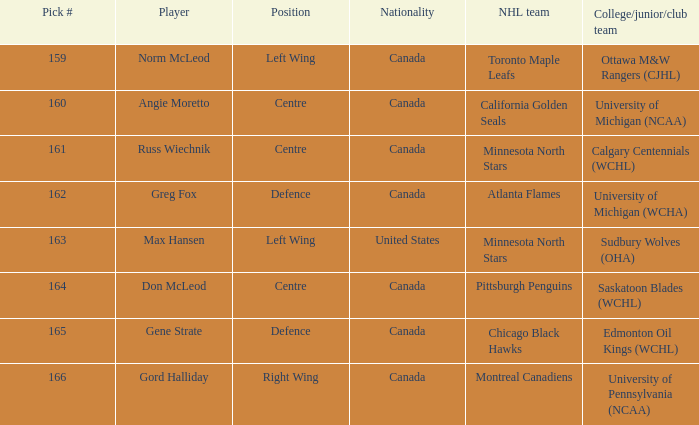Would you mind parsing the complete table? {'header': ['Pick #', 'Player', 'Position', 'Nationality', 'NHL team', 'College/junior/club team'], 'rows': [['159', 'Norm McLeod', 'Left Wing', 'Canada', 'Toronto Maple Leafs', 'Ottawa M&W Rangers (CJHL)'], ['160', 'Angie Moretto', 'Centre', 'Canada', 'California Golden Seals', 'University of Michigan (NCAA)'], ['161', 'Russ Wiechnik', 'Centre', 'Canada', 'Minnesota North Stars', 'Calgary Centennials (WCHL)'], ['162', 'Greg Fox', 'Defence', 'Canada', 'Atlanta Flames', 'University of Michigan (WCHA)'], ['163', 'Max Hansen', 'Left Wing', 'United States', 'Minnesota North Stars', 'Sudbury Wolves (OHA)'], ['164', 'Don McLeod', 'Centre', 'Canada', 'Pittsburgh Penguins', 'Saskatoon Blades (WCHL)'], ['165', 'Gene Strate', 'Defence', 'Canada', 'Chicago Black Hawks', 'Edmonton Oil Kings (WCHL)'], ['166', 'Gord Halliday', 'Right Wing', 'Canada', 'Montreal Canadiens', 'University of Pennsylvania (NCAA)']]} What NHL team was the player from Calgary Centennials (WCHL) drafted for? Minnesota North Stars. 